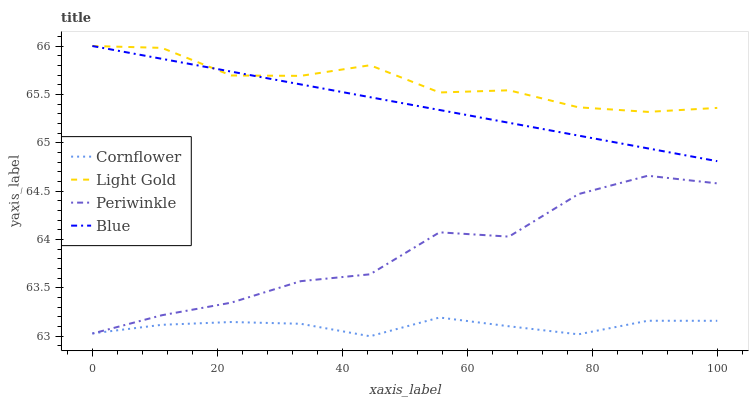Does Periwinkle have the minimum area under the curve?
Answer yes or no. No. Does Periwinkle have the maximum area under the curve?
Answer yes or no. No. Is Cornflower the smoothest?
Answer yes or no. No. Is Cornflower the roughest?
Answer yes or no. No. Does Periwinkle have the lowest value?
Answer yes or no. No. Does Periwinkle have the highest value?
Answer yes or no. No. Is Periwinkle less than Light Gold?
Answer yes or no. Yes. Is Blue greater than Cornflower?
Answer yes or no. Yes. Does Periwinkle intersect Light Gold?
Answer yes or no. No. 